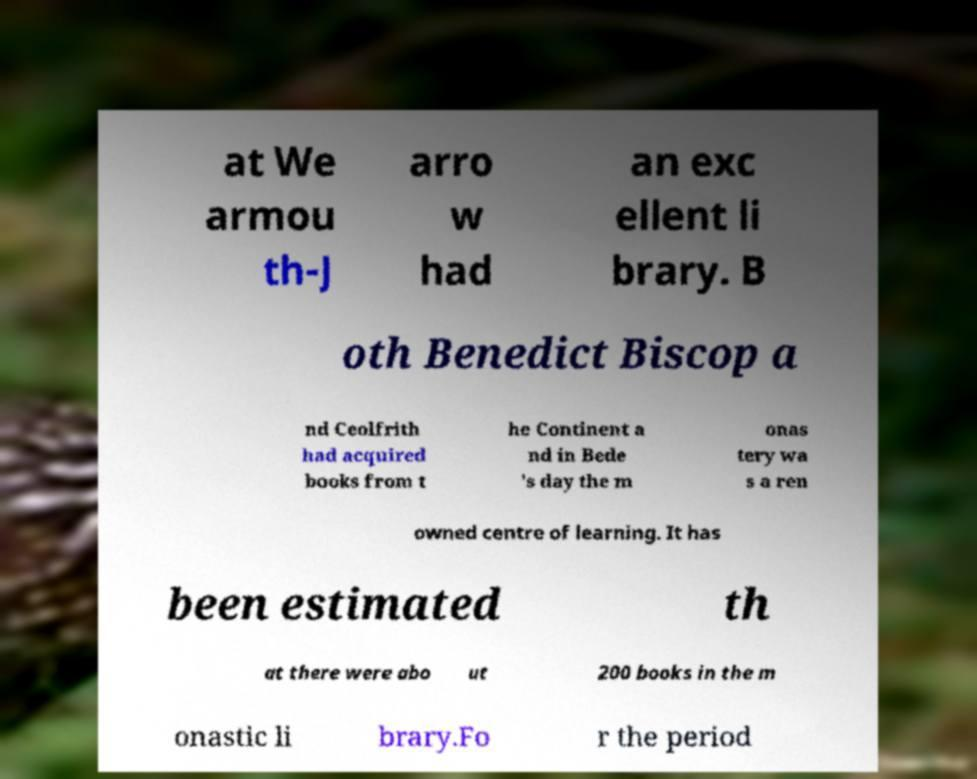Could you extract and type out the text from this image? at We armou th-J arro w had an exc ellent li brary. B oth Benedict Biscop a nd Ceolfrith had acquired books from t he Continent a nd in Bede 's day the m onas tery wa s a ren owned centre of learning. It has been estimated th at there were abo ut 200 books in the m onastic li brary.Fo r the period 